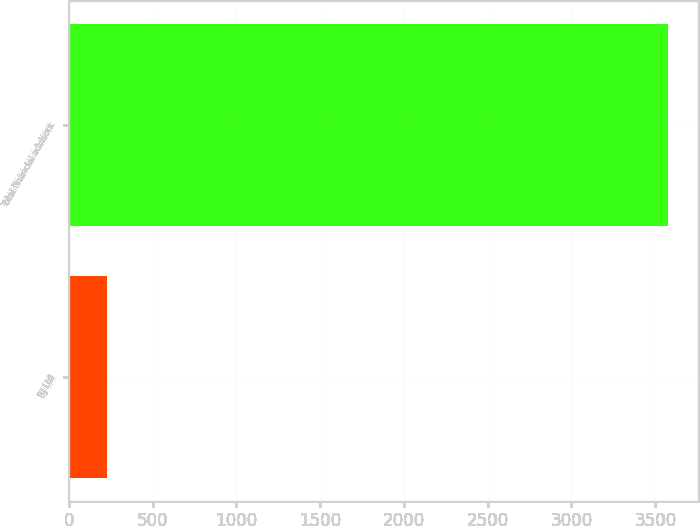Convert chart. <chart><loc_0><loc_0><loc_500><loc_500><bar_chart><fcel>RJ Ltd<fcel>Total financial advisors<nl><fcel>230<fcel>3578<nl></chart> 